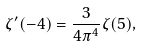Convert formula to latex. <formula><loc_0><loc_0><loc_500><loc_500>\zeta ^ { \prime } ( - 4 ) = \frac { 3 } { 4 \pi ^ { 4 } } \zeta ( 5 ) ,</formula> 